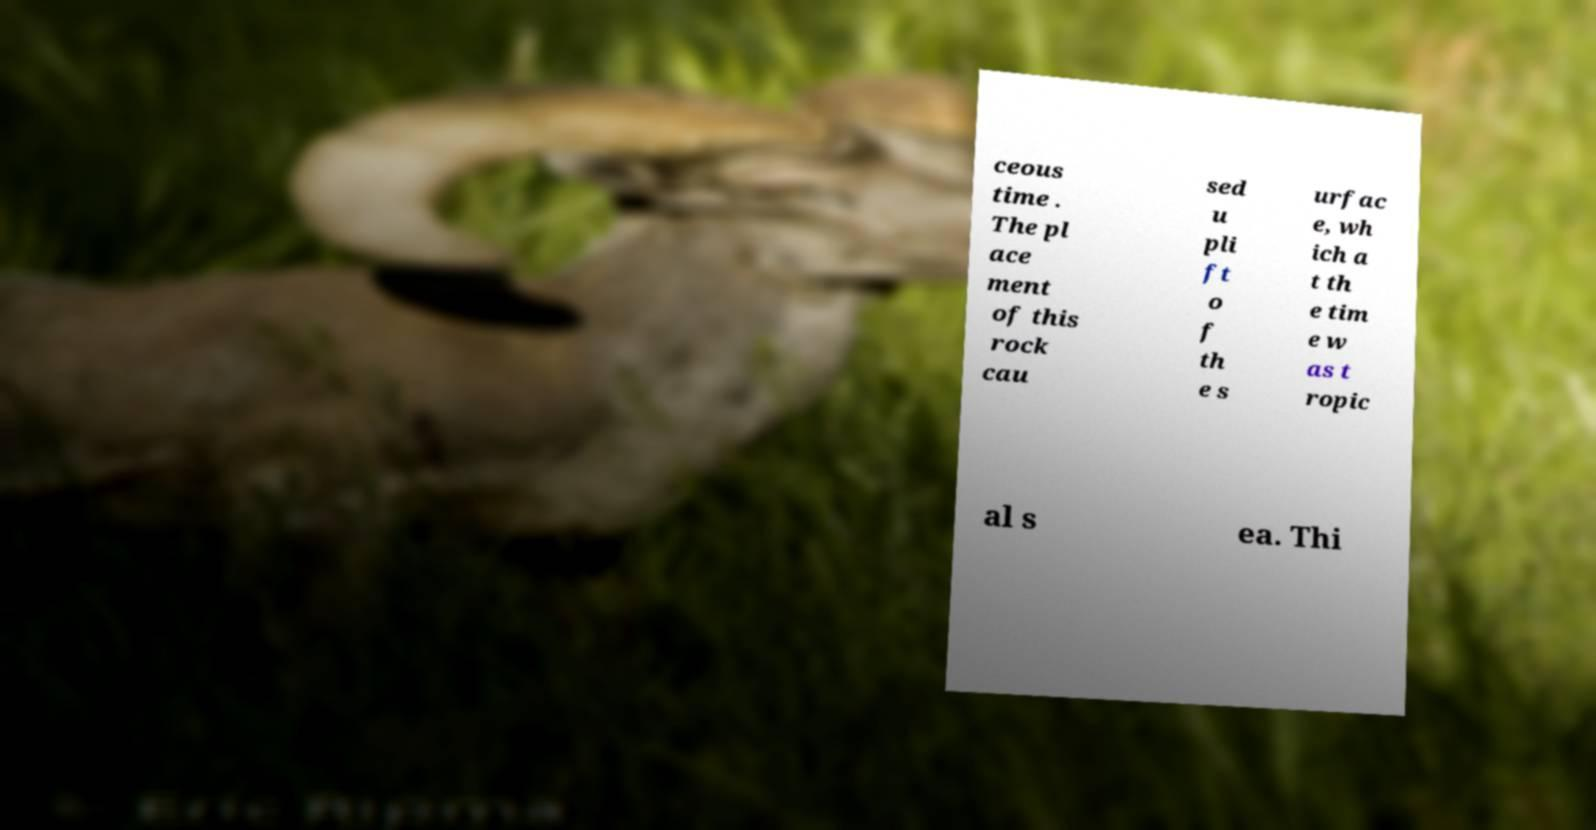Can you read and provide the text displayed in the image?This photo seems to have some interesting text. Can you extract and type it out for me? ceous time . The pl ace ment of this rock cau sed u pli ft o f th e s urfac e, wh ich a t th e tim e w as t ropic al s ea. Thi 